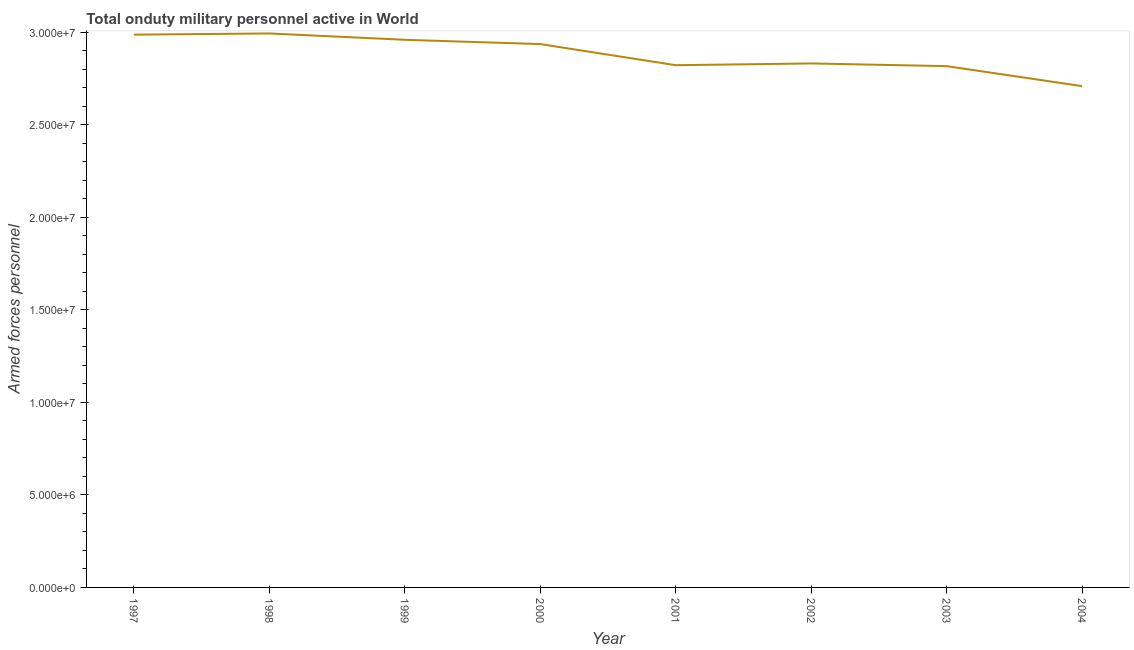What is the number of armed forces personnel in 2002?
Offer a very short reply. 2.83e+07. Across all years, what is the maximum number of armed forces personnel?
Keep it short and to the point. 2.99e+07. Across all years, what is the minimum number of armed forces personnel?
Your answer should be very brief. 2.71e+07. What is the sum of the number of armed forces personnel?
Your answer should be compact. 2.30e+08. What is the difference between the number of armed forces personnel in 1998 and 2000?
Ensure brevity in your answer.  5.74e+05. What is the average number of armed forces personnel per year?
Keep it short and to the point. 2.88e+07. What is the median number of armed forces personnel?
Give a very brief answer. 2.88e+07. What is the ratio of the number of armed forces personnel in 2000 to that in 2004?
Make the answer very short. 1.08. What is the difference between the highest and the second highest number of armed forces personnel?
Your response must be concise. 6.34e+04. What is the difference between the highest and the lowest number of armed forces personnel?
Your response must be concise. 2.85e+06. In how many years, is the number of armed forces personnel greater than the average number of armed forces personnel taken over all years?
Offer a terse response. 4. Does the number of armed forces personnel monotonically increase over the years?
Give a very brief answer. No. Does the graph contain grids?
Your answer should be compact. No. What is the title of the graph?
Make the answer very short. Total onduty military personnel active in World. What is the label or title of the X-axis?
Keep it short and to the point. Year. What is the label or title of the Y-axis?
Give a very brief answer. Armed forces personnel. What is the Armed forces personnel of 1997?
Offer a very short reply. 2.99e+07. What is the Armed forces personnel of 1998?
Provide a succinct answer. 2.99e+07. What is the Armed forces personnel of 1999?
Ensure brevity in your answer.  2.96e+07. What is the Armed forces personnel of 2000?
Your response must be concise. 2.94e+07. What is the Armed forces personnel of 2001?
Your answer should be compact. 2.82e+07. What is the Armed forces personnel in 2002?
Give a very brief answer. 2.83e+07. What is the Armed forces personnel of 2003?
Give a very brief answer. 2.82e+07. What is the Armed forces personnel of 2004?
Your answer should be compact. 2.71e+07. What is the difference between the Armed forces personnel in 1997 and 1998?
Provide a short and direct response. -6.34e+04. What is the difference between the Armed forces personnel in 1997 and 1999?
Provide a short and direct response. 2.79e+05. What is the difference between the Armed forces personnel in 1997 and 2000?
Keep it short and to the point. 5.10e+05. What is the difference between the Armed forces personnel in 1997 and 2001?
Your answer should be compact. 1.65e+06. What is the difference between the Armed forces personnel in 1997 and 2002?
Make the answer very short. 1.56e+06. What is the difference between the Armed forces personnel in 1997 and 2003?
Keep it short and to the point. 1.70e+06. What is the difference between the Armed forces personnel in 1997 and 2004?
Offer a terse response. 2.78e+06. What is the difference between the Armed forces personnel in 1998 and 1999?
Offer a very short reply. 3.43e+05. What is the difference between the Armed forces personnel in 1998 and 2000?
Provide a short and direct response. 5.74e+05. What is the difference between the Armed forces personnel in 1998 and 2001?
Offer a terse response. 1.71e+06. What is the difference between the Armed forces personnel in 1998 and 2002?
Give a very brief answer. 1.62e+06. What is the difference between the Armed forces personnel in 1998 and 2003?
Ensure brevity in your answer.  1.77e+06. What is the difference between the Armed forces personnel in 1998 and 2004?
Your answer should be compact. 2.85e+06. What is the difference between the Armed forces personnel in 1999 and 2000?
Your answer should be compact. 2.31e+05. What is the difference between the Armed forces personnel in 1999 and 2001?
Give a very brief answer. 1.37e+06. What is the difference between the Armed forces personnel in 1999 and 2002?
Ensure brevity in your answer.  1.28e+06. What is the difference between the Armed forces personnel in 1999 and 2003?
Ensure brevity in your answer.  1.42e+06. What is the difference between the Armed forces personnel in 1999 and 2004?
Your answer should be compact. 2.50e+06. What is the difference between the Armed forces personnel in 2000 and 2001?
Your answer should be compact. 1.14e+06. What is the difference between the Armed forces personnel in 2000 and 2002?
Keep it short and to the point. 1.05e+06. What is the difference between the Armed forces personnel in 2000 and 2003?
Ensure brevity in your answer.  1.19e+06. What is the difference between the Armed forces personnel in 2000 and 2004?
Provide a short and direct response. 2.27e+06. What is the difference between the Armed forces personnel in 2001 and 2002?
Your answer should be compact. -9.52e+04. What is the difference between the Armed forces personnel in 2001 and 2003?
Provide a short and direct response. 5.03e+04. What is the difference between the Armed forces personnel in 2001 and 2004?
Give a very brief answer. 1.13e+06. What is the difference between the Armed forces personnel in 2002 and 2003?
Your response must be concise. 1.46e+05. What is the difference between the Armed forces personnel in 2002 and 2004?
Offer a very short reply. 1.23e+06. What is the difference between the Armed forces personnel in 2003 and 2004?
Provide a short and direct response. 1.08e+06. What is the ratio of the Armed forces personnel in 1997 to that in 2001?
Offer a terse response. 1.06. What is the ratio of the Armed forces personnel in 1997 to that in 2002?
Provide a short and direct response. 1.05. What is the ratio of the Armed forces personnel in 1997 to that in 2003?
Make the answer very short. 1.06. What is the ratio of the Armed forces personnel in 1997 to that in 2004?
Your response must be concise. 1.1. What is the ratio of the Armed forces personnel in 1998 to that in 1999?
Your response must be concise. 1.01. What is the ratio of the Armed forces personnel in 1998 to that in 2001?
Keep it short and to the point. 1.06. What is the ratio of the Armed forces personnel in 1998 to that in 2002?
Your response must be concise. 1.06. What is the ratio of the Armed forces personnel in 1998 to that in 2003?
Offer a terse response. 1.06. What is the ratio of the Armed forces personnel in 1998 to that in 2004?
Provide a succinct answer. 1.1. What is the ratio of the Armed forces personnel in 1999 to that in 2000?
Your response must be concise. 1.01. What is the ratio of the Armed forces personnel in 1999 to that in 2001?
Provide a short and direct response. 1.05. What is the ratio of the Armed forces personnel in 1999 to that in 2002?
Offer a terse response. 1.04. What is the ratio of the Armed forces personnel in 1999 to that in 2003?
Give a very brief answer. 1.05. What is the ratio of the Armed forces personnel in 1999 to that in 2004?
Keep it short and to the point. 1.09. What is the ratio of the Armed forces personnel in 2000 to that in 2001?
Offer a terse response. 1.04. What is the ratio of the Armed forces personnel in 2000 to that in 2002?
Your answer should be very brief. 1.04. What is the ratio of the Armed forces personnel in 2000 to that in 2003?
Make the answer very short. 1.04. What is the ratio of the Armed forces personnel in 2000 to that in 2004?
Ensure brevity in your answer.  1.08. What is the ratio of the Armed forces personnel in 2001 to that in 2003?
Ensure brevity in your answer.  1. What is the ratio of the Armed forces personnel in 2001 to that in 2004?
Offer a terse response. 1.04. What is the ratio of the Armed forces personnel in 2002 to that in 2004?
Offer a terse response. 1.04. What is the ratio of the Armed forces personnel in 2003 to that in 2004?
Give a very brief answer. 1.04. 